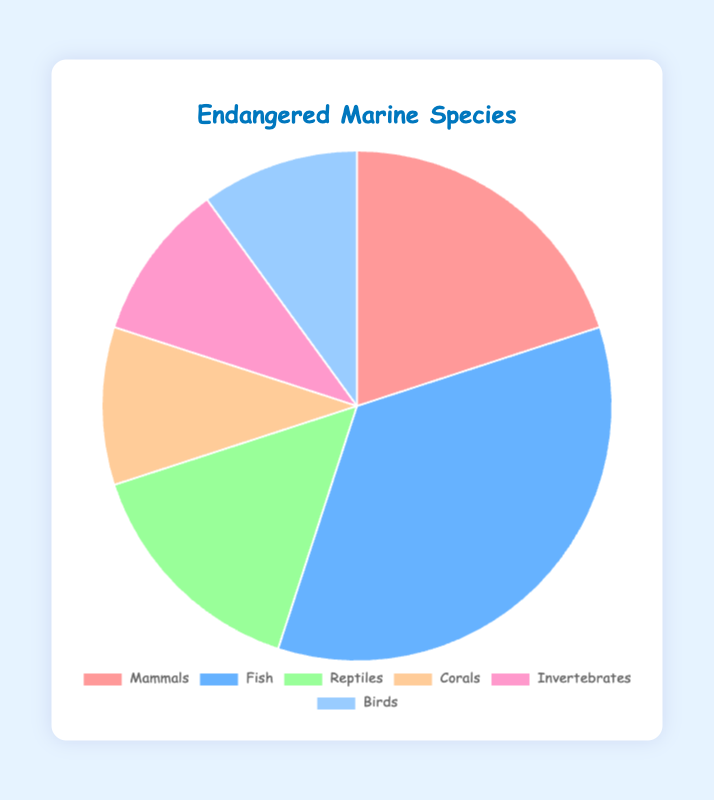Which category has the highest percentage of endangered species? Look at the largest segment in the pie chart. The "Fish" category takes up 35%, which is the highest percentage.
Answer: Fish Which category has the smallest percentage of endangered species? Look at the smallest segment in the pie chart. The "Corals", "Invertebrates", and "Birds" categories each take up 10%, which is the smallest percentage.
Answer: Corals, Invertebrates, and Birds What is the combined percentage of endangered species for Mammals and Fish? Add the percentages for Mammals (20%) and Fish (35%): 20% + 35% = 55%
Answer: 55% Is the percentage of endangered Reptiles greater than the combined percentage of Corals and Invertebrates? Compare the percentages: Reptiles are 15%, and the combined percentage of Corals and Invertebrates is 10% + 10% = 20%. Since 15% is not greater than 20%, the answer is no.
Answer: No What percentage of endangered species are either Birds or Mammals? Add the percentages for Birds (10%) and Mammals (20%): 10% + 20% = 30%
Answer: 30% Which category has a percentage twice as high as the Reptiles category? Reptiles have 15%. Double that is 15% * 2 = 30%. None of the categories have exactly 30%, so the answer is none.
Answer: None What is the difference in percentage points between the Fish and Reptiles categories? Subtract the Reptiles percentage from the Fish percentage: 35% - 15% = 20%.
Answer: 20% How many categories have exactly a 10% share of endangered species? Identify the categories with a 10% share: Corals, Invertebrates, and Birds. There are three such categories.
Answer: 3 Are Fish more endangered than all the other categories combined? The percentage for Fish is 35%. The sum of all other categories is 100% - 35% = 65%. Since 35% is less than 65%, Fish are not more endangered than all other categories combined.
Answer: No What is the average percentage of all endangered categories excluding Birds? Exclude Birds (10%), then average the remaining percentages (20% for Mammals, 35% for Fish, 15% for Reptiles, 10% for Corals, and 10% for Invertebrates): (20% + 35% + 15% + 10% + 10%) / 5 = 18%
Answer: 18% 